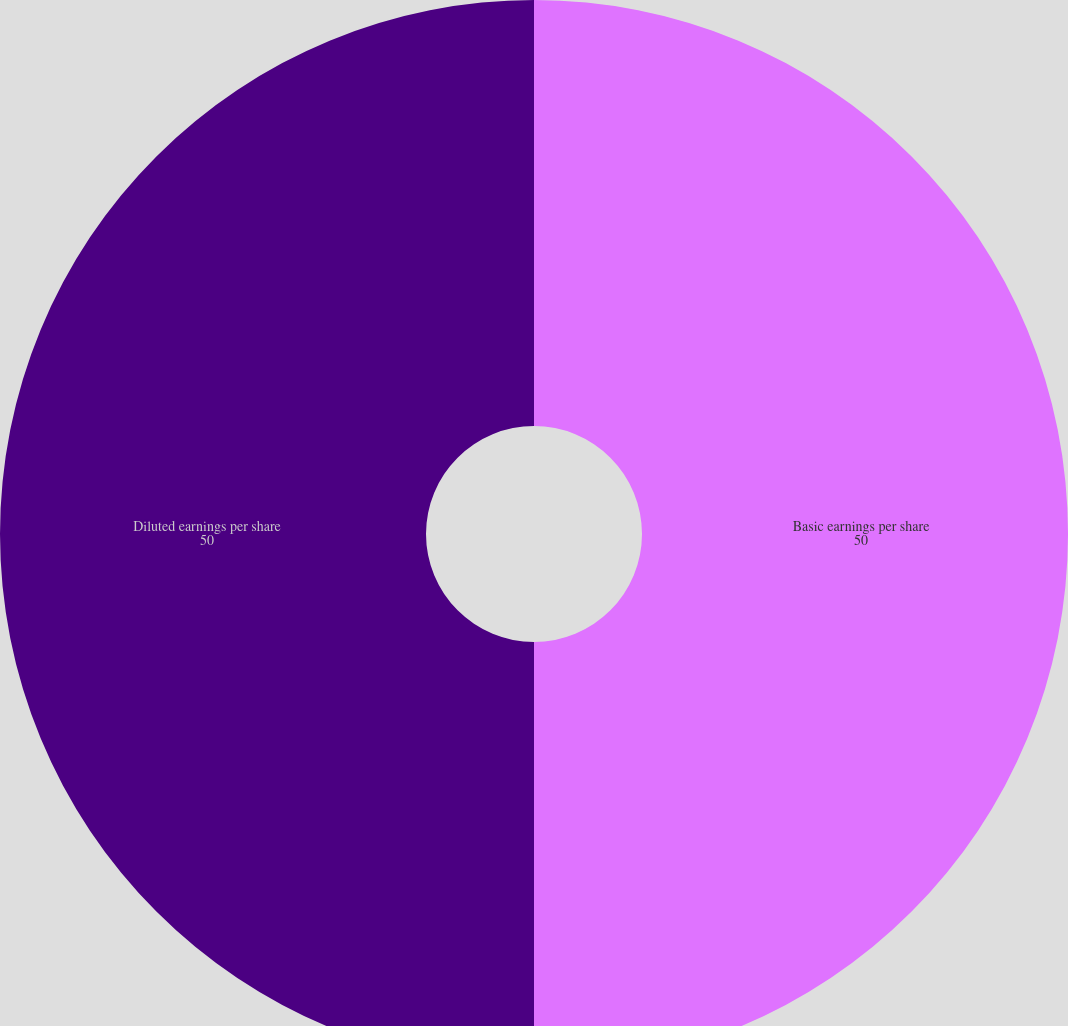<chart> <loc_0><loc_0><loc_500><loc_500><pie_chart><fcel>Basic earnings per share<fcel>Diluted earnings per share<nl><fcel>50.0%<fcel>50.0%<nl></chart> 